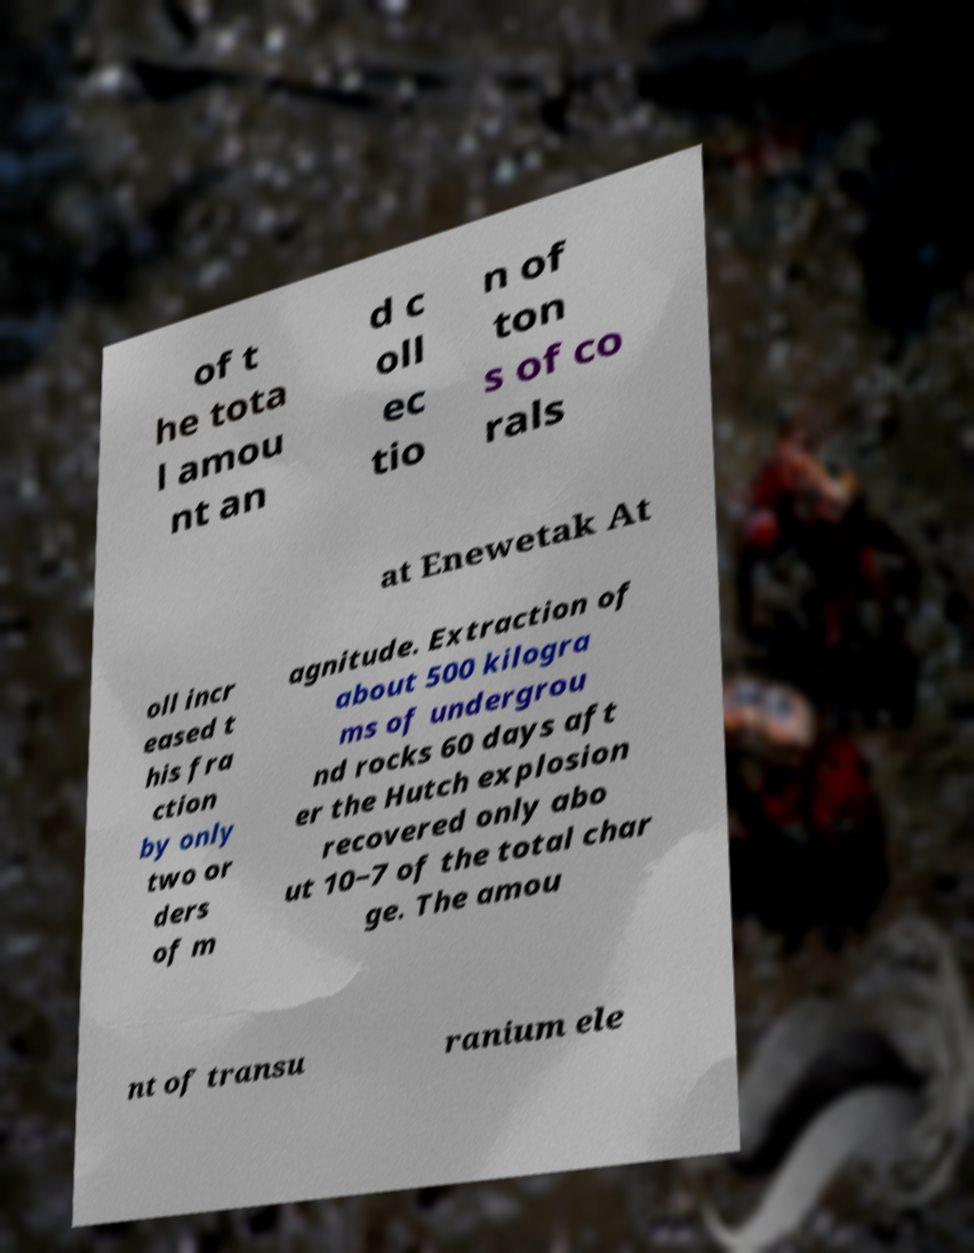Please identify and transcribe the text found in this image. of t he tota l amou nt an d c oll ec tio n of ton s of co rals at Enewetak At oll incr eased t his fra ction by only two or ders of m agnitude. Extraction of about 500 kilogra ms of undergrou nd rocks 60 days aft er the Hutch explosion recovered only abo ut 10−7 of the total char ge. The amou nt of transu ranium ele 